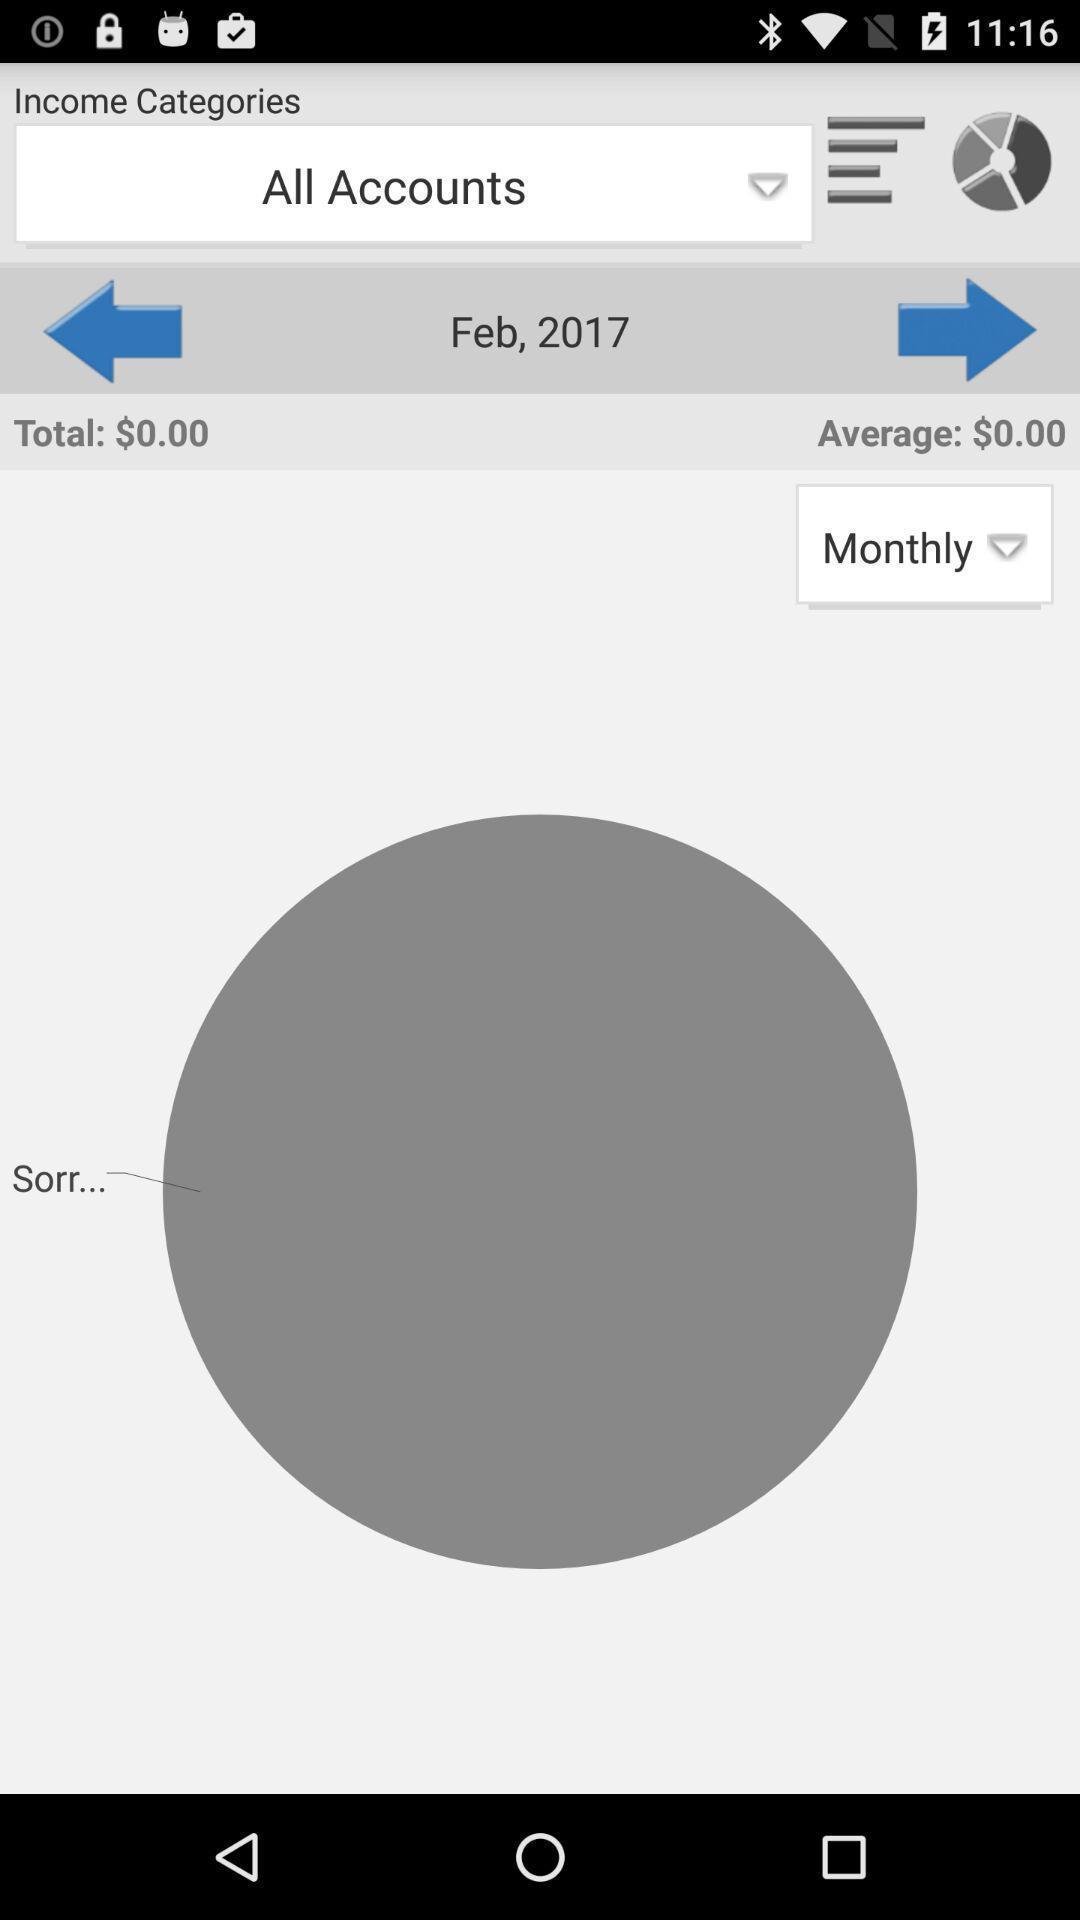Explain the elements present in this screenshot. Screen shows all accounts in a finance app. 